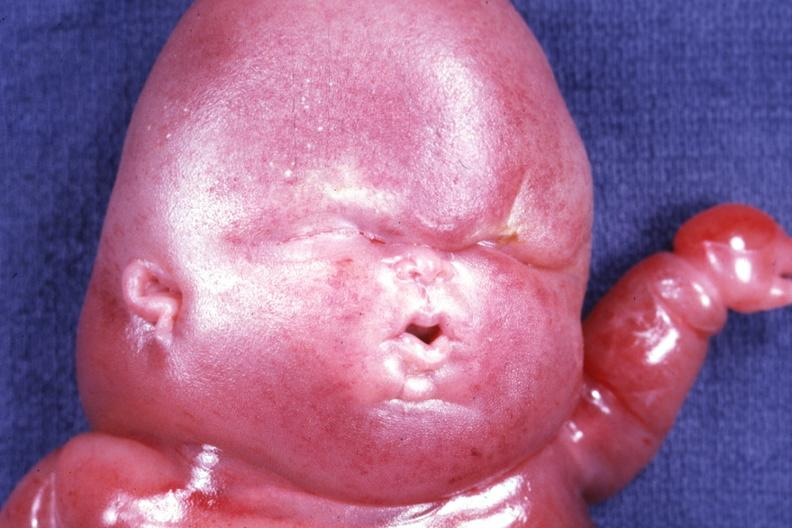does surface show mostly head in photo gory edema?
Answer the question using a single word or phrase. No 